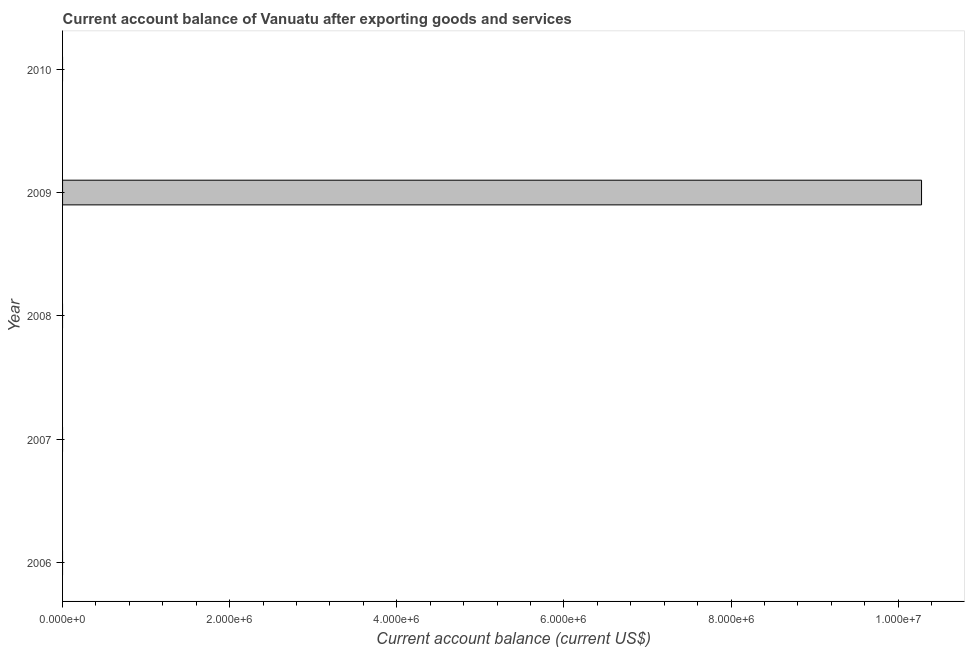What is the title of the graph?
Provide a succinct answer. Current account balance of Vanuatu after exporting goods and services. What is the label or title of the X-axis?
Provide a succinct answer. Current account balance (current US$). What is the current account balance in 2009?
Offer a very short reply. 1.03e+07. Across all years, what is the maximum current account balance?
Provide a succinct answer. 1.03e+07. Across all years, what is the minimum current account balance?
Keep it short and to the point. 0. In which year was the current account balance maximum?
Provide a succinct answer. 2009. What is the sum of the current account balance?
Give a very brief answer. 1.03e+07. What is the average current account balance per year?
Your answer should be compact. 2.06e+06. What is the difference between the highest and the lowest current account balance?
Your answer should be compact. 1.03e+07. How many bars are there?
Your answer should be compact. 1. Are all the bars in the graph horizontal?
Your response must be concise. Yes. How many years are there in the graph?
Your response must be concise. 5. What is the difference between two consecutive major ticks on the X-axis?
Your answer should be very brief. 2.00e+06. What is the Current account balance (current US$) of 2007?
Give a very brief answer. 0. What is the Current account balance (current US$) in 2009?
Offer a very short reply. 1.03e+07. What is the Current account balance (current US$) of 2010?
Your answer should be very brief. 0. 